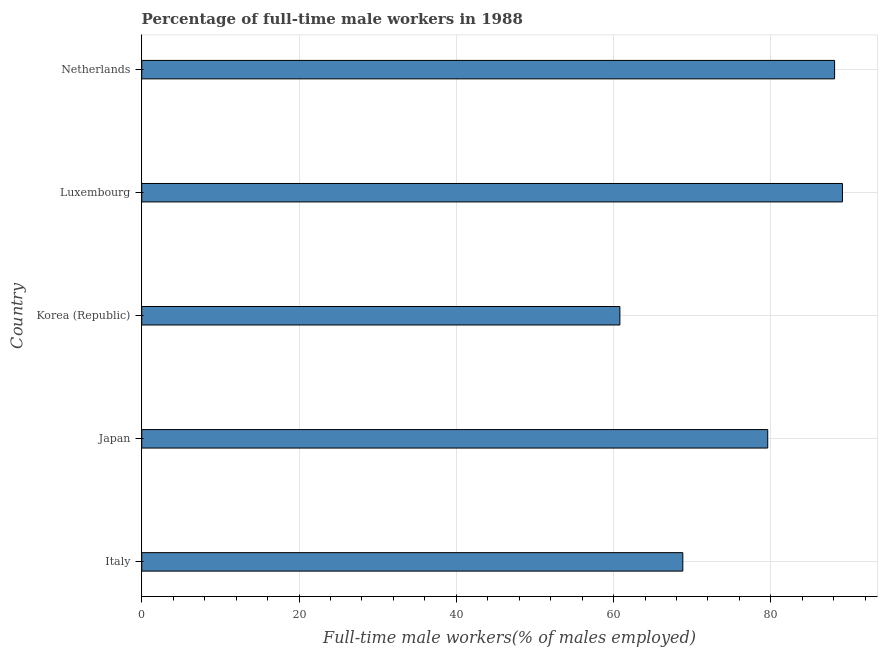Does the graph contain any zero values?
Your answer should be very brief. No. Does the graph contain grids?
Make the answer very short. Yes. What is the title of the graph?
Provide a succinct answer. Percentage of full-time male workers in 1988. What is the label or title of the X-axis?
Ensure brevity in your answer.  Full-time male workers(% of males employed). What is the label or title of the Y-axis?
Offer a very short reply. Country. What is the percentage of full-time male workers in Korea (Republic)?
Your answer should be compact. 60.8. Across all countries, what is the maximum percentage of full-time male workers?
Your answer should be compact. 89.1. Across all countries, what is the minimum percentage of full-time male workers?
Your response must be concise. 60.8. In which country was the percentage of full-time male workers maximum?
Give a very brief answer. Luxembourg. What is the sum of the percentage of full-time male workers?
Offer a terse response. 386.4. What is the difference between the percentage of full-time male workers in Korea (Republic) and Netherlands?
Offer a very short reply. -27.3. What is the average percentage of full-time male workers per country?
Provide a short and direct response. 77.28. What is the median percentage of full-time male workers?
Provide a succinct answer. 79.6. What is the ratio of the percentage of full-time male workers in Italy to that in Luxembourg?
Offer a terse response. 0.77. What is the difference between the highest and the second highest percentage of full-time male workers?
Your response must be concise. 1. What is the difference between the highest and the lowest percentage of full-time male workers?
Give a very brief answer. 28.3. In how many countries, is the percentage of full-time male workers greater than the average percentage of full-time male workers taken over all countries?
Make the answer very short. 3. Are the values on the major ticks of X-axis written in scientific E-notation?
Offer a terse response. No. What is the Full-time male workers(% of males employed) of Italy?
Offer a terse response. 68.8. What is the Full-time male workers(% of males employed) in Japan?
Provide a short and direct response. 79.6. What is the Full-time male workers(% of males employed) of Korea (Republic)?
Ensure brevity in your answer.  60.8. What is the Full-time male workers(% of males employed) in Luxembourg?
Keep it short and to the point. 89.1. What is the Full-time male workers(% of males employed) of Netherlands?
Provide a succinct answer. 88.1. What is the difference between the Full-time male workers(% of males employed) in Italy and Japan?
Offer a terse response. -10.8. What is the difference between the Full-time male workers(% of males employed) in Italy and Luxembourg?
Keep it short and to the point. -20.3. What is the difference between the Full-time male workers(% of males employed) in Italy and Netherlands?
Provide a succinct answer. -19.3. What is the difference between the Full-time male workers(% of males employed) in Japan and Korea (Republic)?
Your response must be concise. 18.8. What is the difference between the Full-time male workers(% of males employed) in Japan and Luxembourg?
Keep it short and to the point. -9.5. What is the difference between the Full-time male workers(% of males employed) in Japan and Netherlands?
Give a very brief answer. -8.5. What is the difference between the Full-time male workers(% of males employed) in Korea (Republic) and Luxembourg?
Your response must be concise. -28.3. What is the difference between the Full-time male workers(% of males employed) in Korea (Republic) and Netherlands?
Offer a terse response. -27.3. What is the ratio of the Full-time male workers(% of males employed) in Italy to that in Japan?
Your answer should be compact. 0.86. What is the ratio of the Full-time male workers(% of males employed) in Italy to that in Korea (Republic)?
Give a very brief answer. 1.13. What is the ratio of the Full-time male workers(% of males employed) in Italy to that in Luxembourg?
Your answer should be very brief. 0.77. What is the ratio of the Full-time male workers(% of males employed) in Italy to that in Netherlands?
Ensure brevity in your answer.  0.78. What is the ratio of the Full-time male workers(% of males employed) in Japan to that in Korea (Republic)?
Provide a short and direct response. 1.31. What is the ratio of the Full-time male workers(% of males employed) in Japan to that in Luxembourg?
Your answer should be very brief. 0.89. What is the ratio of the Full-time male workers(% of males employed) in Japan to that in Netherlands?
Your answer should be very brief. 0.9. What is the ratio of the Full-time male workers(% of males employed) in Korea (Republic) to that in Luxembourg?
Your answer should be compact. 0.68. What is the ratio of the Full-time male workers(% of males employed) in Korea (Republic) to that in Netherlands?
Ensure brevity in your answer.  0.69. 